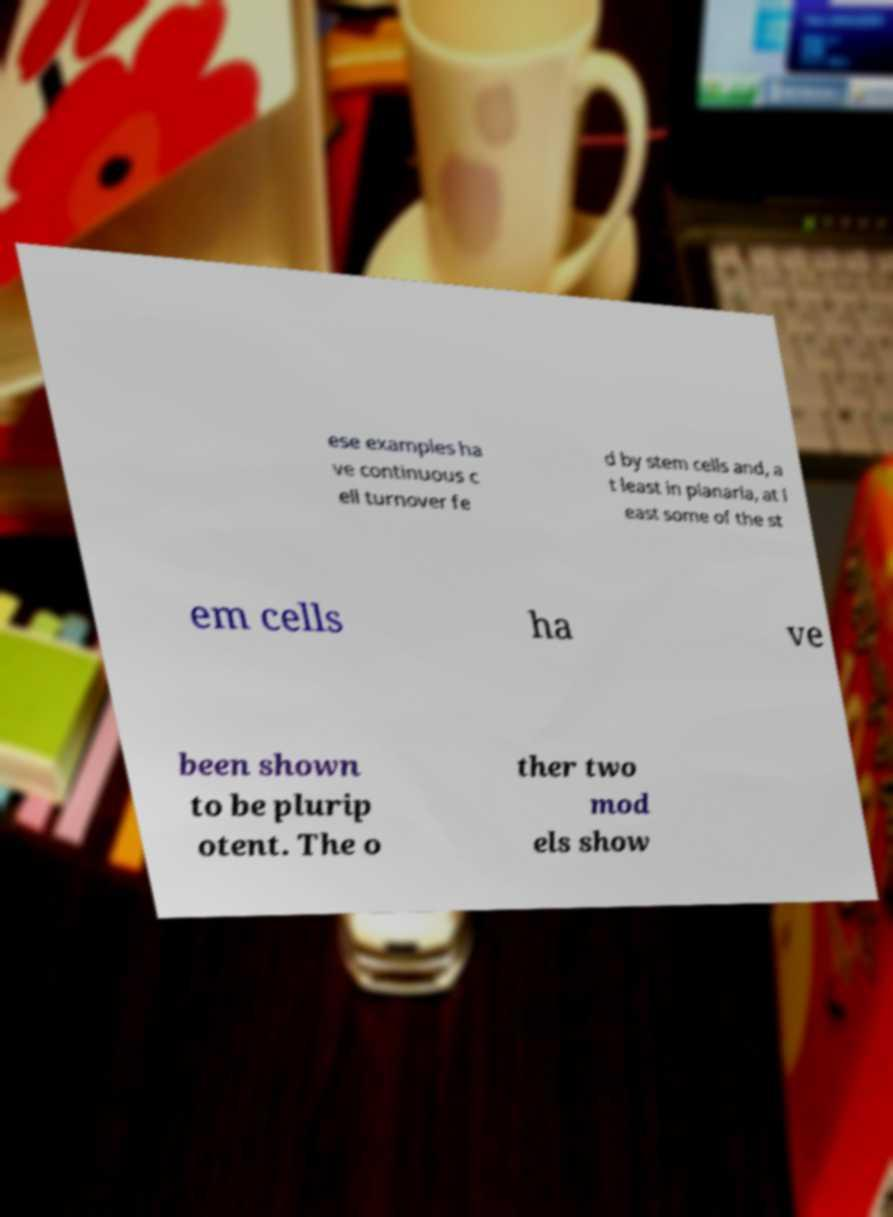Please read and relay the text visible in this image. What does it say? ese examples ha ve continuous c ell turnover fe d by stem cells and, a t least in planaria, at l east some of the st em cells ha ve been shown to be plurip otent. The o ther two mod els show 